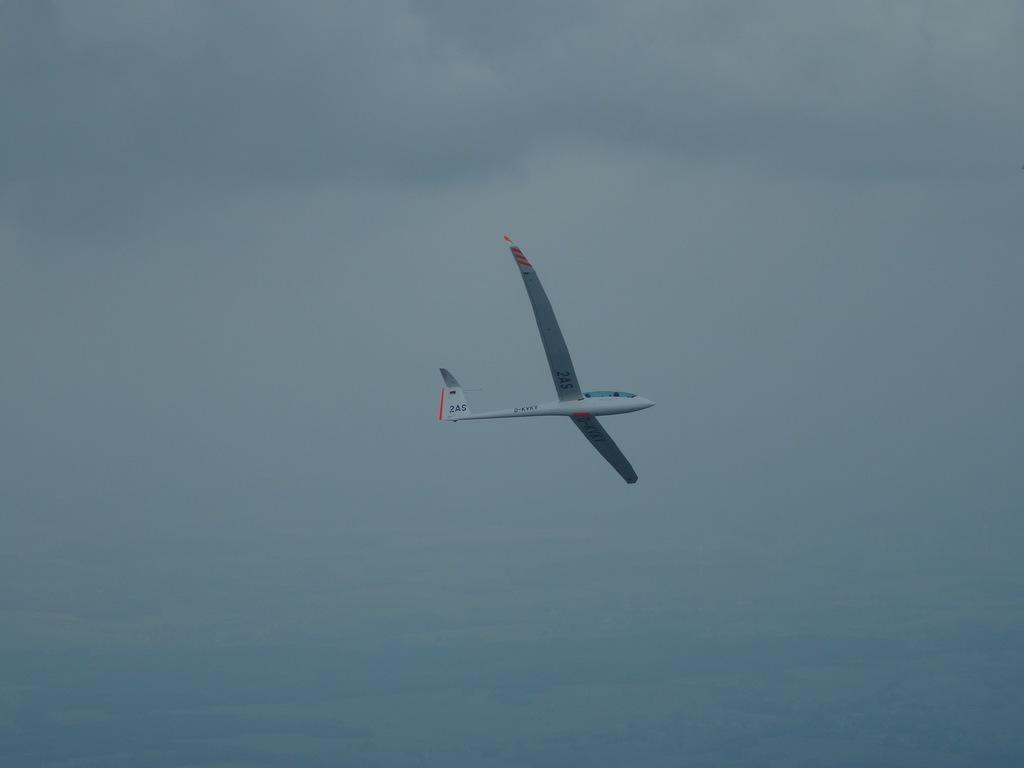What is the main subject of the image? The main subject of the image is an aircraft. What is the aircraft doing in the image? The aircraft is flying in the air. What can be seen in the background of the image? There are clouds in the sky in the background of the image. Can you see any fangs on the aircraft in the image? There are no fangs present on the aircraft in the image. Is there a lake visible in the image? There is no lake visible in the image; it features an aircraft flying in the air with clouds in the background. 